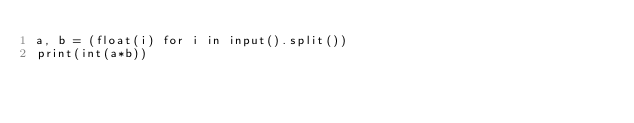Convert code to text. <code><loc_0><loc_0><loc_500><loc_500><_Python_>a, b = (float(i) for i in input().split())
print(int(a*b))</code> 